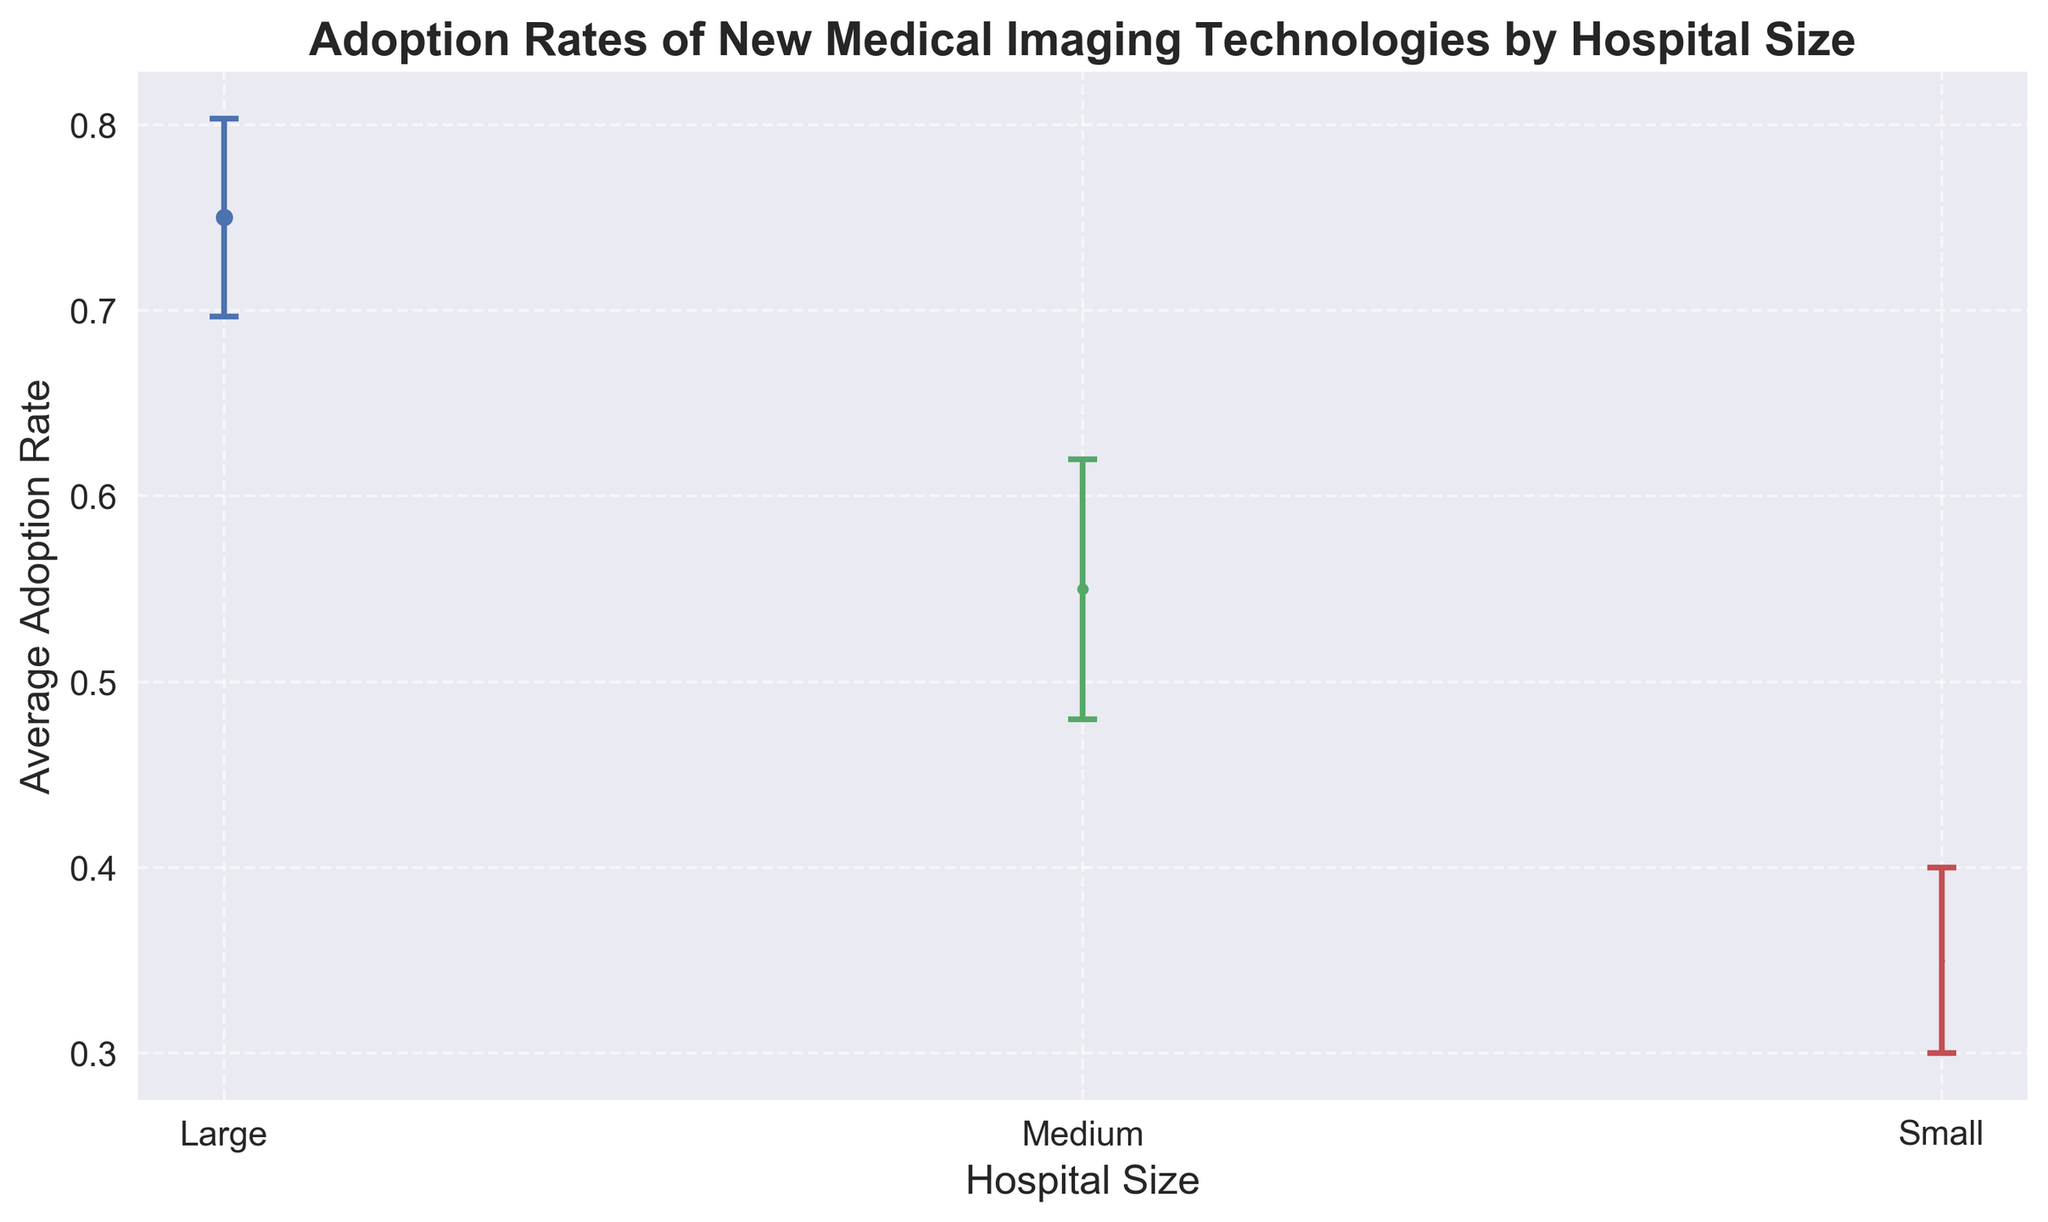What is the average adoption rate for large hospitals? To find the average adoption rate for large hospitals, locate the "Large" bars on the chart and note their height. Since we have three data points for "Large", calculate the mean of these. (0.75 + 0.70 + 0.80) / 3 = 0.75
Answer: 0.75 Which hospital size has the highest average adoption rate? Identify the bar with the highest height. The "Large" hospital size bar is the highest, indicating that large hospitals have the highest adoption rate.
Answer: Large Compare the average adoption rates of medium and small hospitals. Which is higher? Compare the height of the bars representing "Medium" and "Small". The bar for "Medium" is higher than the bar for "Small", indicating that medium hospitals have a higher adoption rate.
Answer: Medium What is the difference between the average adoption rates of medium and small hospitals? Note the average adoption rates from the chart: Medium is 0.55, Small is 0.35. Subtract the smaller from the larger: 0.55 - 0.35 = 0.2
Answer: 0.2 Do all hospital sizes have similar variances in adoption rates? Look at the error bars (lines extending above and below the points) for each hospital size. Compare their lengths. The lengths of the error bars are different, indicating varying degrees of variance.
Answer: No What is the range of adoption rates for small hospitals as indicated by the error bars? Locate the "Small" error bars and observe their heights. They range from 0.30 up to 0.40.
Answer: 0.30 - 0.40 How does the adoption rate variance of medium hospitals compare to that of large hospitals? Look at the lengths of the error bars for "Medium" and "Large" hospitals. Medium hospitals have longer error bars than large hospitals, indicating greater variance.
Answer: Medium hospitals have greater variance What is the combined mean adoption rate for small and large hospitals? Find the adoption rates for both "Small" and "Large" from the chart. Small's mean is 0.35 and Large's is 0.75. The combined mean is (0.35 + 0.75) / 2 = 0.55
Answer: 0.55 